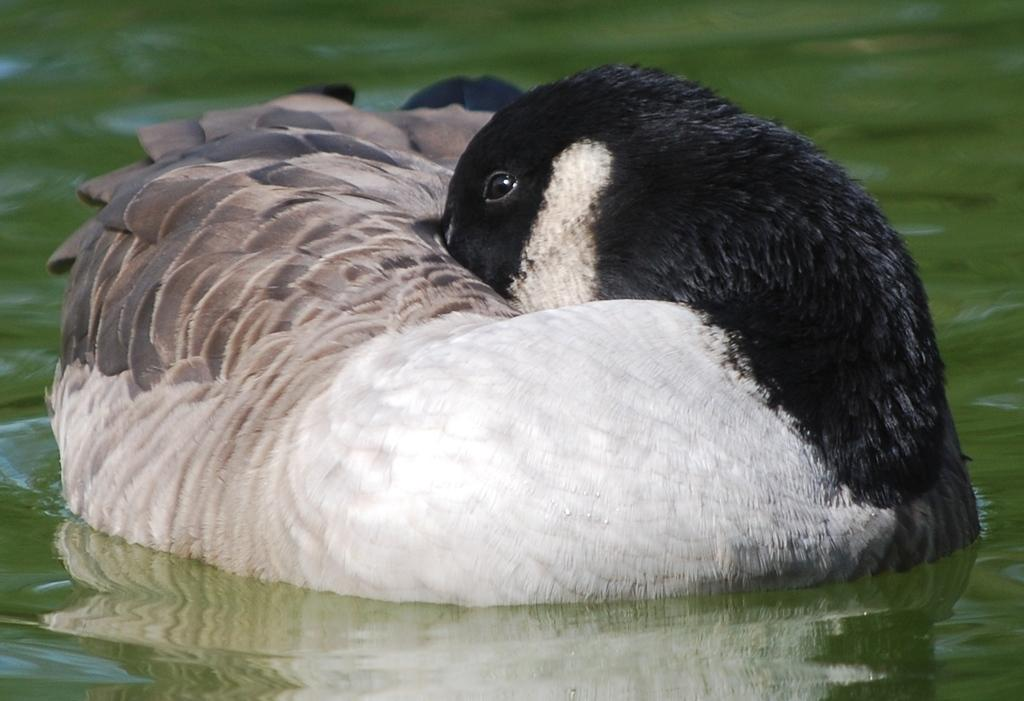What animal is in the foreground of the image? There is a duck in the foreground of the image. Where is the duck located? The duck is on the water. What type of grain is being harvested in the image? There is no reference to grain or any harvesting activity in the image; it features a duck on the water. What word is being spelled out by the duck in the image? There is no indication that the duck is spelling out any word in the image. 